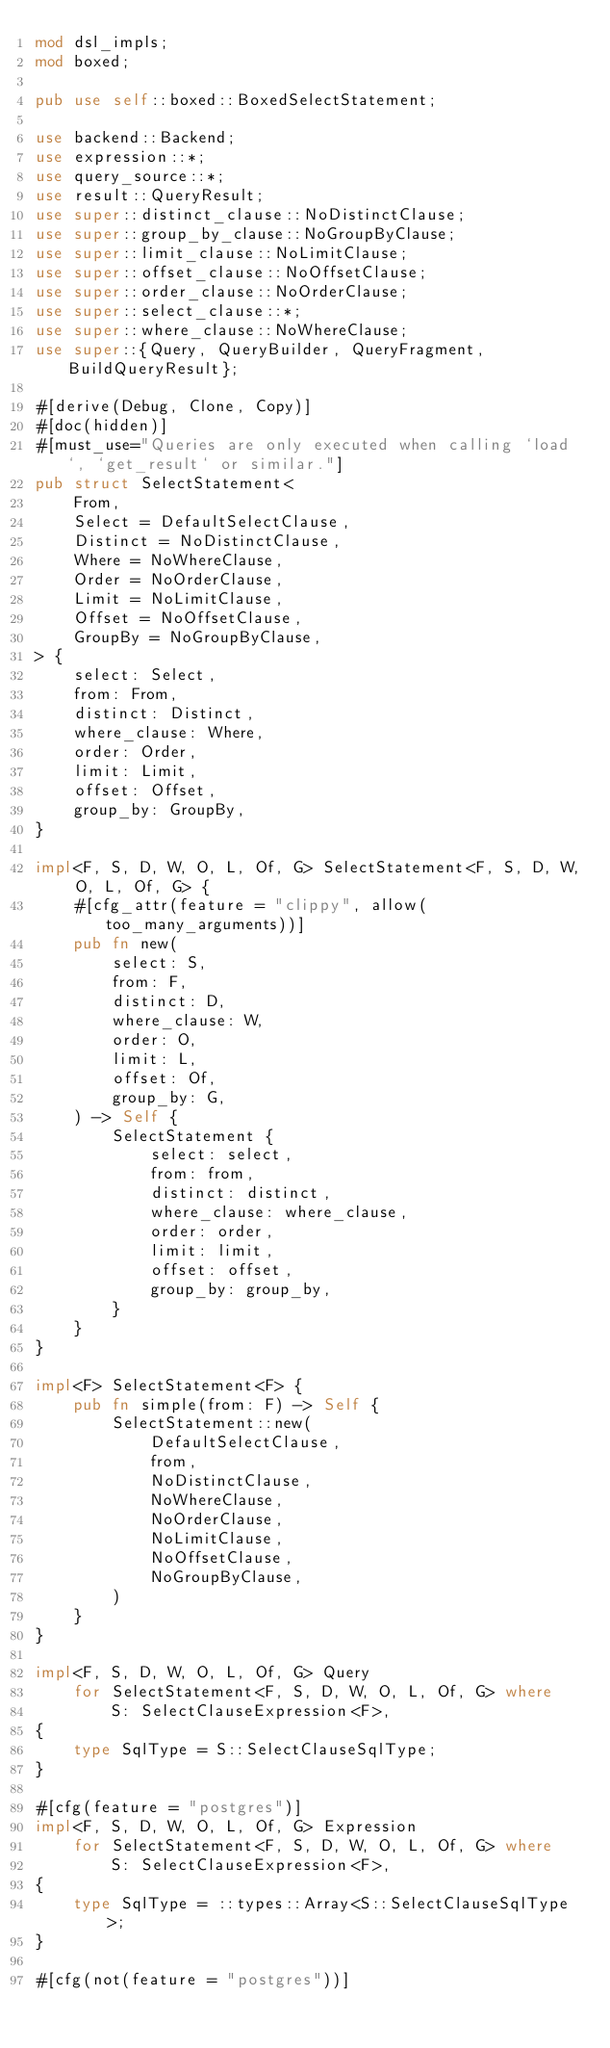<code> <loc_0><loc_0><loc_500><loc_500><_Rust_>mod dsl_impls;
mod boxed;

pub use self::boxed::BoxedSelectStatement;

use backend::Backend;
use expression::*;
use query_source::*;
use result::QueryResult;
use super::distinct_clause::NoDistinctClause;
use super::group_by_clause::NoGroupByClause;
use super::limit_clause::NoLimitClause;
use super::offset_clause::NoOffsetClause;
use super::order_clause::NoOrderClause;
use super::select_clause::*;
use super::where_clause::NoWhereClause;
use super::{Query, QueryBuilder, QueryFragment, BuildQueryResult};

#[derive(Debug, Clone, Copy)]
#[doc(hidden)]
#[must_use="Queries are only executed when calling `load`, `get_result` or similar."]
pub struct SelectStatement<
    From,
    Select = DefaultSelectClause,
    Distinct = NoDistinctClause,
    Where = NoWhereClause,
    Order = NoOrderClause,
    Limit = NoLimitClause,
    Offset = NoOffsetClause,
    GroupBy = NoGroupByClause,
> {
    select: Select,
    from: From,
    distinct: Distinct,
    where_clause: Where,
    order: Order,
    limit: Limit,
    offset: Offset,
    group_by: GroupBy,
}

impl<F, S, D, W, O, L, Of, G> SelectStatement<F, S, D, W, O, L, Of, G> {
    #[cfg_attr(feature = "clippy", allow(too_many_arguments))]
    pub fn new(
        select: S,
        from: F,
        distinct: D,
        where_clause: W,
        order: O,
        limit: L,
        offset: Of,
        group_by: G,
    ) -> Self {
        SelectStatement {
            select: select,
            from: from,
            distinct: distinct,
            where_clause: where_clause,
            order: order,
            limit: limit,
            offset: offset,
            group_by: group_by,
        }
    }
}

impl<F> SelectStatement<F> {
    pub fn simple(from: F) -> Self {
        SelectStatement::new(
            DefaultSelectClause,
            from,
            NoDistinctClause,
            NoWhereClause,
            NoOrderClause,
            NoLimitClause,
            NoOffsetClause,
            NoGroupByClause,
        )
    }
}

impl<F, S, D, W, O, L, Of, G> Query
    for SelectStatement<F, S, D, W, O, L, Of, G> where
        S: SelectClauseExpression<F>,
{
    type SqlType = S::SelectClauseSqlType;
}

#[cfg(feature = "postgres")]
impl<F, S, D, W, O, L, Of, G> Expression
    for SelectStatement<F, S, D, W, O, L, Of, G> where
        S: SelectClauseExpression<F>,
{
    type SqlType = ::types::Array<S::SelectClauseSqlType>;
}

#[cfg(not(feature = "postgres"))]</code> 